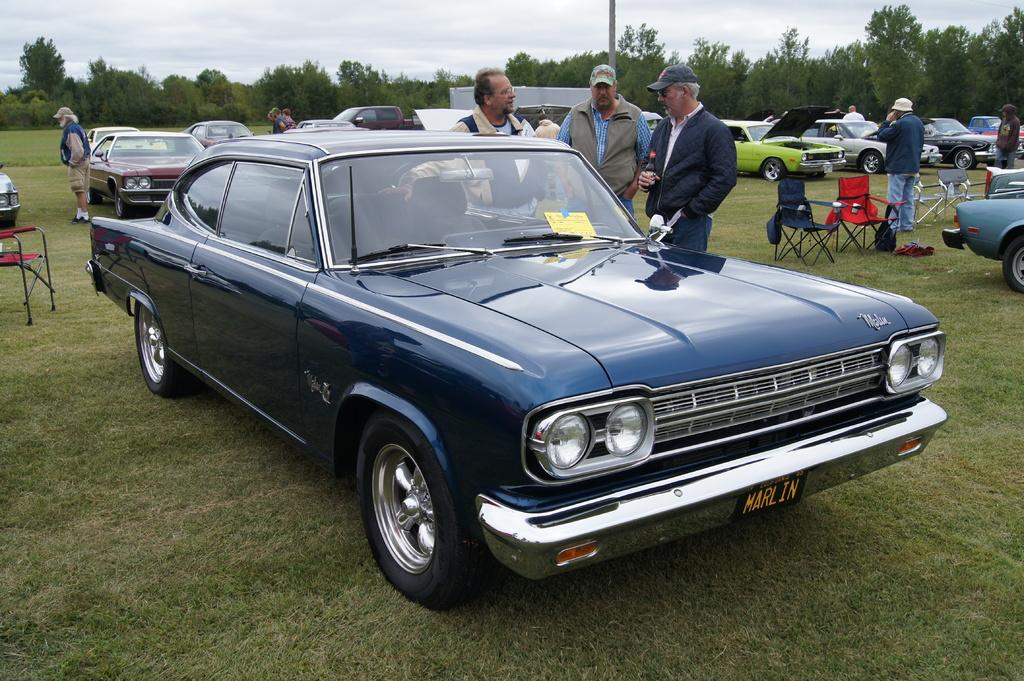<image>
Give a short and clear explanation of the subsequent image. Three middle-age white men are standing near a classic car with California plates reading MARLIN. 